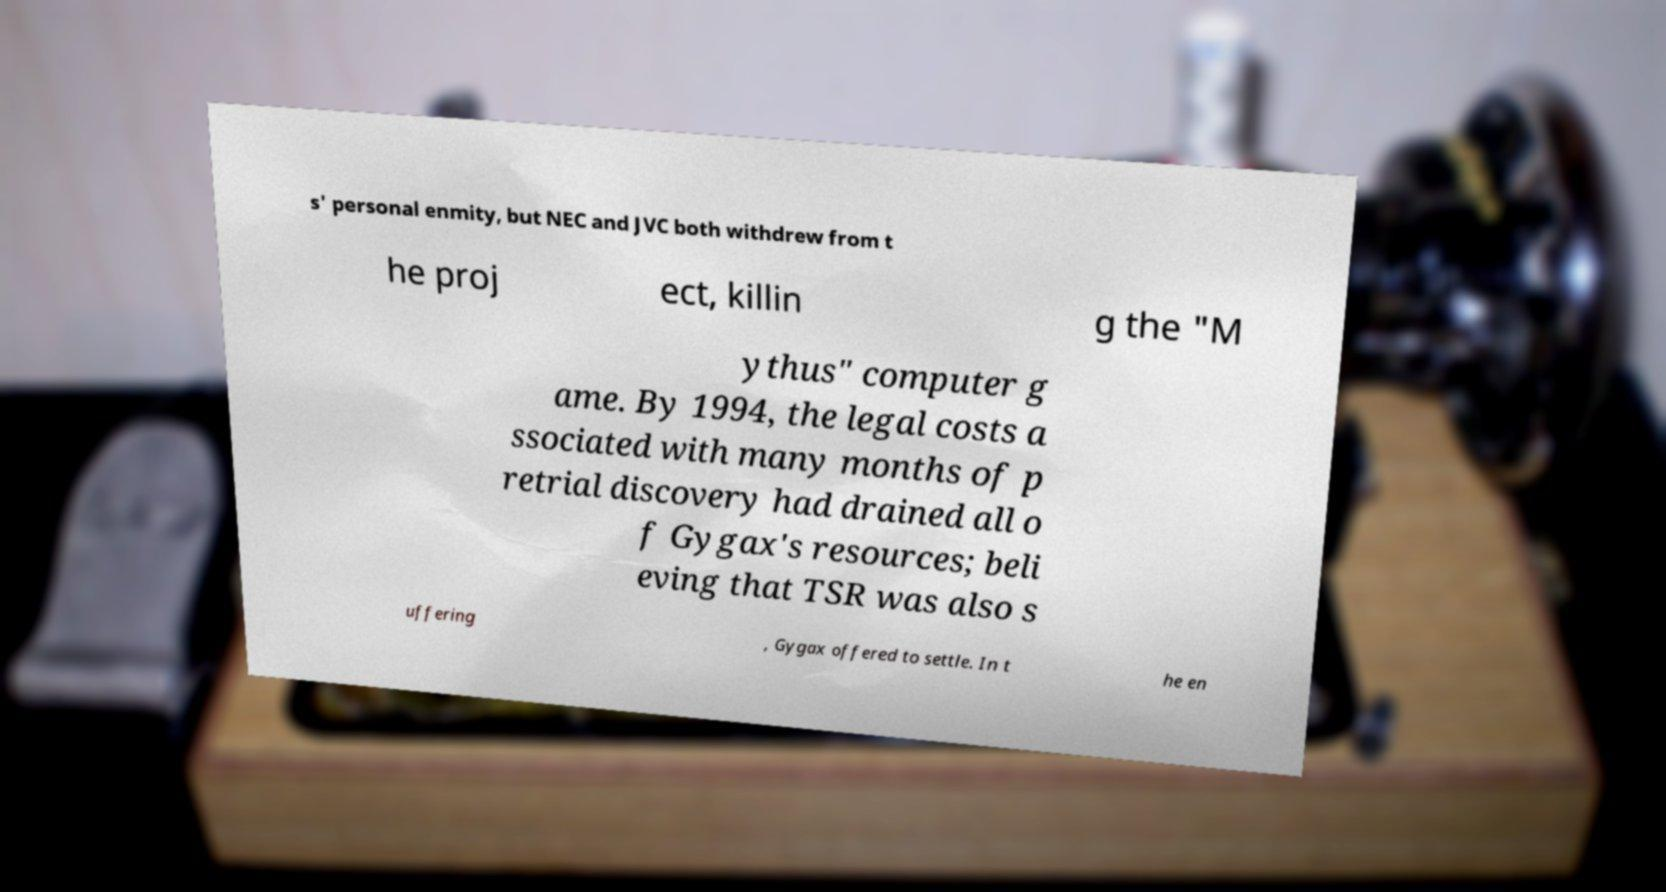For documentation purposes, I need the text within this image transcribed. Could you provide that? s' personal enmity, but NEC and JVC both withdrew from t he proj ect, killin g the "M ythus" computer g ame. By 1994, the legal costs a ssociated with many months of p retrial discovery had drained all o f Gygax's resources; beli eving that TSR was also s uffering , Gygax offered to settle. In t he en 